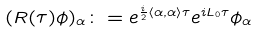Convert formula to latex. <formula><loc_0><loc_0><loc_500><loc_500>( R ( \tau ) \phi ) _ { \alpha } \colon = e ^ { \frac { i } { 2 } \left \langle \alpha , \alpha \right \rangle \tau } e ^ { i L _ { 0 } \tau } \phi _ { \alpha }</formula> 